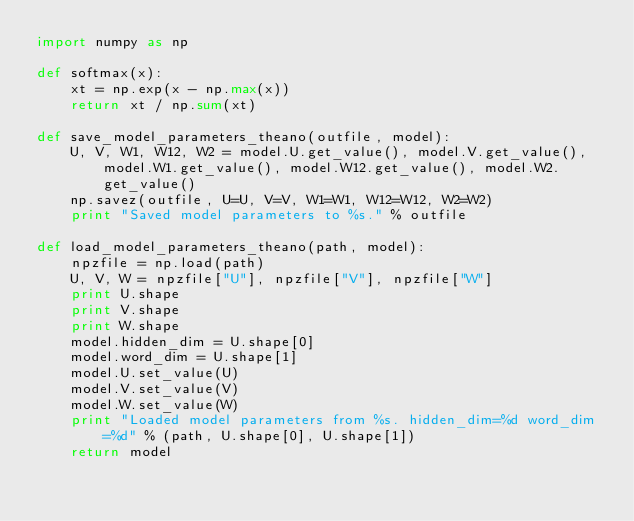<code> <loc_0><loc_0><loc_500><loc_500><_Python_>import numpy as np

def softmax(x):
    xt = np.exp(x - np.max(x))
    return xt / np.sum(xt)

def save_model_parameters_theano(outfile, model):
    U, V, W1, W12, W2 = model.U.get_value(), model.V.get_value(), model.W1.get_value(), model.W12.get_value(), model.W2.get_value()
    np.savez(outfile, U=U, V=V, W1=W1, W12=W12, W2=W2)
    print "Saved model parameters to %s." % outfile
   
def load_model_parameters_theano(path, model):
    npzfile = np.load(path)
    U, V, W = npzfile["U"], npzfile["V"], npzfile["W"]
    print U.shape
    print V.shape
    print W.shape
    model.hidden_dim = U.shape[0]
    model.word_dim = U.shape[1]
    model.U.set_value(U)
    model.V.set_value(V)
    model.W.set_value(W)
    print "Loaded model parameters from %s. hidden_dim=%d word_dim=%d" % (path, U.shape[0], U.shape[1])
    return model
    </code> 